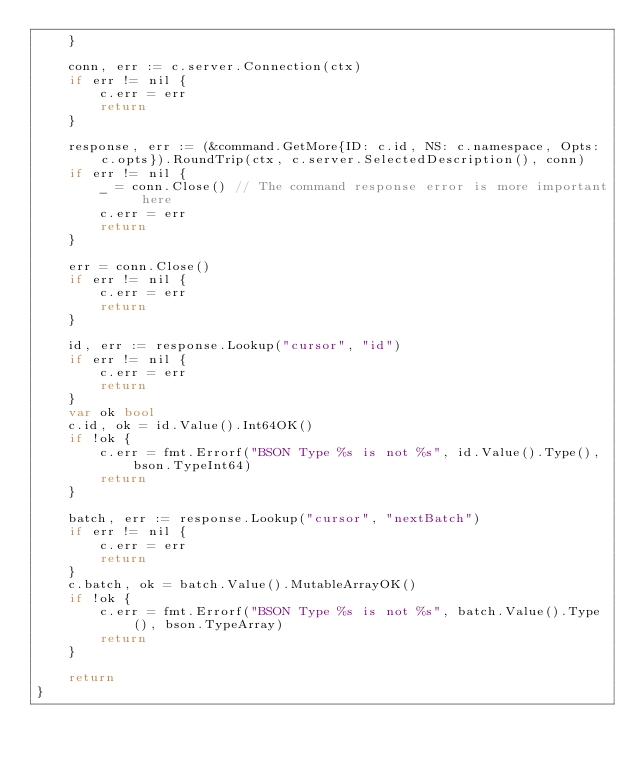<code> <loc_0><loc_0><loc_500><loc_500><_Go_>	}

	conn, err := c.server.Connection(ctx)
	if err != nil {
		c.err = err
		return
	}

	response, err := (&command.GetMore{ID: c.id, NS: c.namespace, Opts: c.opts}).RoundTrip(ctx, c.server.SelectedDescription(), conn)
	if err != nil {
		_ = conn.Close() // The command response error is more important here
		c.err = err
		return
	}

	err = conn.Close()
	if err != nil {
		c.err = err
		return
	}

	id, err := response.Lookup("cursor", "id")
	if err != nil {
		c.err = err
		return
	}
	var ok bool
	c.id, ok = id.Value().Int64OK()
	if !ok {
		c.err = fmt.Errorf("BSON Type %s is not %s", id.Value().Type(), bson.TypeInt64)
		return
	}

	batch, err := response.Lookup("cursor", "nextBatch")
	if err != nil {
		c.err = err
		return
	}
	c.batch, ok = batch.Value().MutableArrayOK()
	if !ok {
		c.err = fmt.Errorf("BSON Type %s is not %s", batch.Value().Type(), bson.TypeArray)
		return
	}

	return
}
</code> 